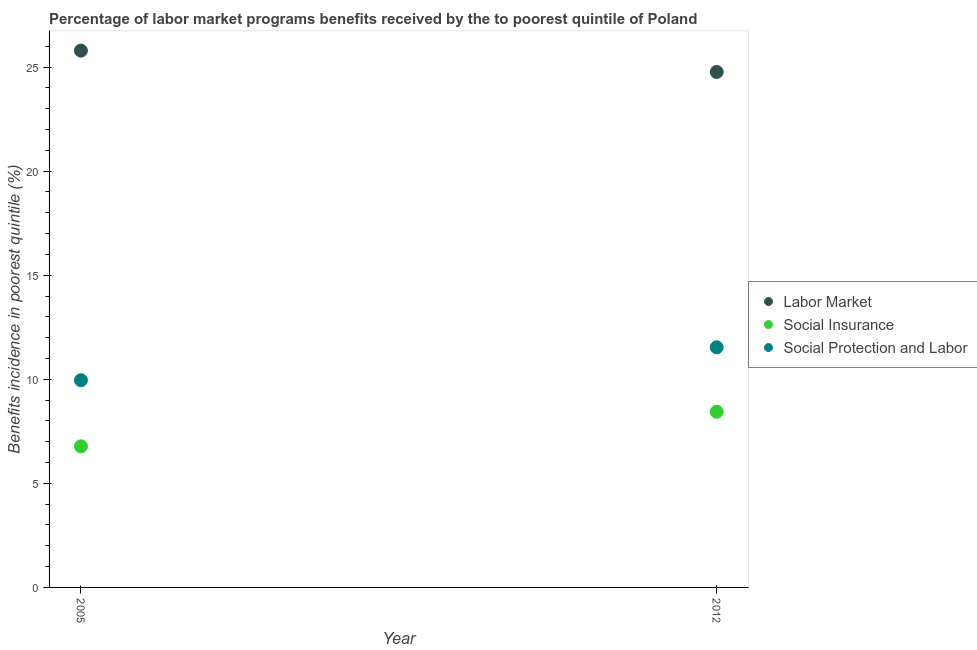How many different coloured dotlines are there?
Make the answer very short. 3. What is the percentage of benefits received due to social protection programs in 2005?
Ensure brevity in your answer.  9.96. Across all years, what is the maximum percentage of benefits received due to social insurance programs?
Keep it short and to the point. 8.44. Across all years, what is the minimum percentage of benefits received due to social insurance programs?
Your answer should be very brief. 6.78. In which year was the percentage of benefits received due to social insurance programs maximum?
Ensure brevity in your answer.  2012. In which year was the percentage of benefits received due to social insurance programs minimum?
Provide a succinct answer. 2005. What is the total percentage of benefits received due to social insurance programs in the graph?
Offer a very short reply. 15.22. What is the difference between the percentage of benefits received due to social insurance programs in 2005 and that in 2012?
Your response must be concise. -1.66. What is the difference between the percentage of benefits received due to social insurance programs in 2012 and the percentage of benefits received due to social protection programs in 2005?
Ensure brevity in your answer.  -1.52. What is the average percentage of benefits received due to social protection programs per year?
Offer a very short reply. 10.75. In the year 2012, what is the difference between the percentage of benefits received due to social insurance programs and percentage of benefits received due to social protection programs?
Make the answer very short. -3.1. In how many years, is the percentage of benefits received due to labor market programs greater than 3 %?
Make the answer very short. 2. What is the ratio of the percentage of benefits received due to labor market programs in 2005 to that in 2012?
Offer a very short reply. 1.04. Is it the case that in every year, the sum of the percentage of benefits received due to labor market programs and percentage of benefits received due to social insurance programs is greater than the percentage of benefits received due to social protection programs?
Give a very brief answer. Yes. Is the percentage of benefits received due to labor market programs strictly greater than the percentage of benefits received due to social insurance programs over the years?
Your answer should be compact. Yes. How many dotlines are there?
Keep it short and to the point. 3. How many years are there in the graph?
Provide a short and direct response. 2. What is the difference between two consecutive major ticks on the Y-axis?
Your response must be concise. 5. Does the graph contain grids?
Provide a succinct answer. No. Where does the legend appear in the graph?
Ensure brevity in your answer.  Center right. How many legend labels are there?
Offer a very short reply. 3. What is the title of the graph?
Your response must be concise. Percentage of labor market programs benefits received by the to poorest quintile of Poland. Does "Poland" appear as one of the legend labels in the graph?
Your answer should be compact. No. What is the label or title of the X-axis?
Provide a succinct answer. Year. What is the label or title of the Y-axis?
Provide a short and direct response. Benefits incidence in poorest quintile (%). What is the Benefits incidence in poorest quintile (%) in Labor Market in 2005?
Give a very brief answer. 25.79. What is the Benefits incidence in poorest quintile (%) of Social Insurance in 2005?
Ensure brevity in your answer.  6.78. What is the Benefits incidence in poorest quintile (%) of Social Protection and Labor in 2005?
Make the answer very short. 9.96. What is the Benefits incidence in poorest quintile (%) of Labor Market in 2012?
Offer a very short reply. 24.76. What is the Benefits incidence in poorest quintile (%) of Social Insurance in 2012?
Give a very brief answer. 8.44. What is the Benefits incidence in poorest quintile (%) of Social Protection and Labor in 2012?
Your answer should be very brief. 11.54. Across all years, what is the maximum Benefits incidence in poorest quintile (%) of Labor Market?
Keep it short and to the point. 25.79. Across all years, what is the maximum Benefits incidence in poorest quintile (%) in Social Insurance?
Keep it short and to the point. 8.44. Across all years, what is the maximum Benefits incidence in poorest quintile (%) in Social Protection and Labor?
Your answer should be compact. 11.54. Across all years, what is the minimum Benefits incidence in poorest quintile (%) of Labor Market?
Ensure brevity in your answer.  24.76. Across all years, what is the minimum Benefits incidence in poorest quintile (%) of Social Insurance?
Keep it short and to the point. 6.78. Across all years, what is the minimum Benefits incidence in poorest quintile (%) in Social Protection and Labor?
Your answer should be compact. 9.96. What is the total Benefits incidence in poorest quintile (%) of Labor Market in the graph?
Offer a terse response. 50.55. What is the total Benefits incidence in poorest quintile (%) of Social Insurance in the graph?
Make the answer very short. 15.22. What is the total Benefits incidence in poorest quintile (%) of Social Protection and Labor in the graph?
Provide a short and direct response. 21.49. What is the difference between the Benefits incidence in poorest quintile (%) in Labor Market in 2005 and that in 2012?
Your answer should be very brief. 1.03. What is the difference between the Benefits incidence in poorest quintile (%) of Social Insurance in 2005 and that in 2012?
Provide a short and direct response. -1.66. What is the difference between the Benefits incidence in poorest quintile (%) of Social Protection and Labor in 2005 and that in 2012?
Keep it short and to the point. -1.58. What is the difference between the Benefits incidence in poorest quintile (%) in Labor Market in 2005 and the Benefits incidence in poorest quintile (%) in Social Insurance in 2012?
Offer a very short reply. 17.35. What is the difference between the Benefits incidence in poorest quintile (%) in Labor Market in 2005 and the Benefits incidence in poorest quintile (%) in Social Protection and Labor in 2012?
Offer a terse response. 14.25. What is the difference between the Benefits incidence in poorest quintile (%) in Social Insurance in 2005 and the Benefits incidence in poorest quintile (%) in Social Protection and Labor in 2012?
Offer a very short reply. -4.76. What is the average Benefits incidence in poorest quintile (%) of Labor Market per year?
Keep it short and to the point. 25.28. What is the average Benefits incidence in poorest quintile (%) in Social Insurance per year?
Your answer should be compact. 7.61. What is the average Benefits incidence in poorest quintile (%) of Social Protection and Labor per year?
Offer a terse response. 10.75. In the year 2005, what is the difference between the Benefits incidence in poorest quintile (%) in Labor Market and Benefits incidence in poorest quintile (%) in Social Insurance?
Provide a short and direct response. 19.01. In the year 2005, what is the difference between the Benefits incidence in poorest quintile (%) in Labor Market and Benefits incidence in poorest quintile (%) in Social Protection and Labor?
Your answer should be compact. 15.83. In the year 2005, what is the difference between the Benefits incidence in poorest quintile (%) in Social Insurance and Benefits incidence in poorest quintile (%) in Social Protection and Labor?
Keep it short and to the point. -3.18. In the year 2012, what is the difference between the Benefits incidence in poorest quintile (%) in Labor Market and Benefits incidence in poorest quintile (%) in Social Insurance?
Provide a succinct answer. 16.32. In the year 2012, what is the difference between the Benefits incidence in poorest quintile (%) of Labor Market and Benefits incidence in poorest quintile (%) of Social Protection and Labor?
Give a very brief answer. 13.23. In the year 2012, what is the difference between the Benefits incidence in poorest quintile (%) of Social Insurance and Benefits incidence in poorest quintile (%) of Social Protection and Labor?
Provide a short and direct response. -3.1. What is the ratio of the Benefits incidence in poorest quintile (%) in Labor Market in 2005 to that in 2012?
Provide a short and direct response. 1.04. What is the ratio of the Benefits incidence in poorest quintile (%) in Social Insurance in 2005 to that in 2012?
Provide a short and direct response. 0.8. What is the ratio of the Benefits incidence in poorest quintile (%) in Social Protection and Labor in 2005 to that in 2012?
Your answer should be compact. 0.86. What is the difference between the highest and the second highest Benefits incidence in poorest quintile (%) of Labor Market?
Ensure brevity in your answer.  1.03. What is the difference between the highest and the second highest Benefits incidence in poorest quintile (%) in Social Insurance?
Provide a short and direct response. 1.66. What is the difference between the highest and the second highest Benefits incidence in poorest quintile (%) in Social Protection and Labor?
Offer a terse response. 1.58. What is the difference between the highest and the lowest Benefits incidence in poorest quintile (%) of Labor Market?
Your answer should be compact. 1.03. What is the difference between the highest and the lowest Benefits incidence in poorest quintile (%) of Social Insurance?
Offer a terse response. 1.66. What is the difference between the highest and the lowest Benefits incidence in poorest quintile (%) of Social Protection and Labor?
Your answer should be compact. 1.58. 